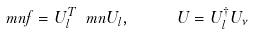Convert formula to latex. <formula><loc_0><loc_0><loc_500><loc_500>\ m n f = U ^ { T } _ { l } \ m n U _ { l } , \quad \ U = U ^ { \dagger } _ { l } U _ { \nu }</formula> 